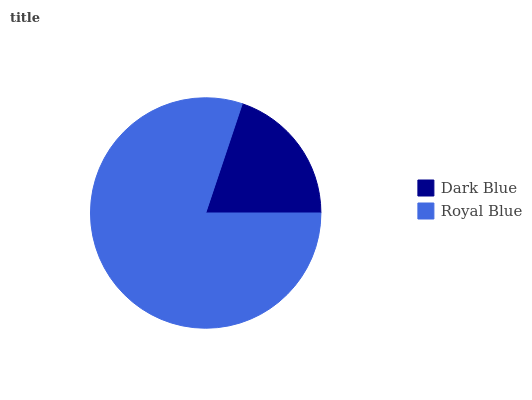Is Dark Blue the minimum?
Answer yes or no. Yes. Is Royal Blue the maximum?
Answer yes or no. Yes. Is Royal Blue the minimum?
Answer yes or no. No. Is Royal Blue greater than Dark Blue?
Answer yes or no. Yes. Is Dark Blue less than Royal Blue?
Answer yes or no. Yes. Is Dark Blue greater than Royal Blue?
Answer yes or no. No. Is Royal Blue less than Dark Blue?
Answer yes or no. No. Is Royal Blue the high median?
Answer yes or no. Yes. Is Dark Blue the low median?
Answer yes or no. Yes. Is Dark Blue the high median?
Answer yes or no. No. Is Royal Blue the low median?
Answer yes or no. No. 